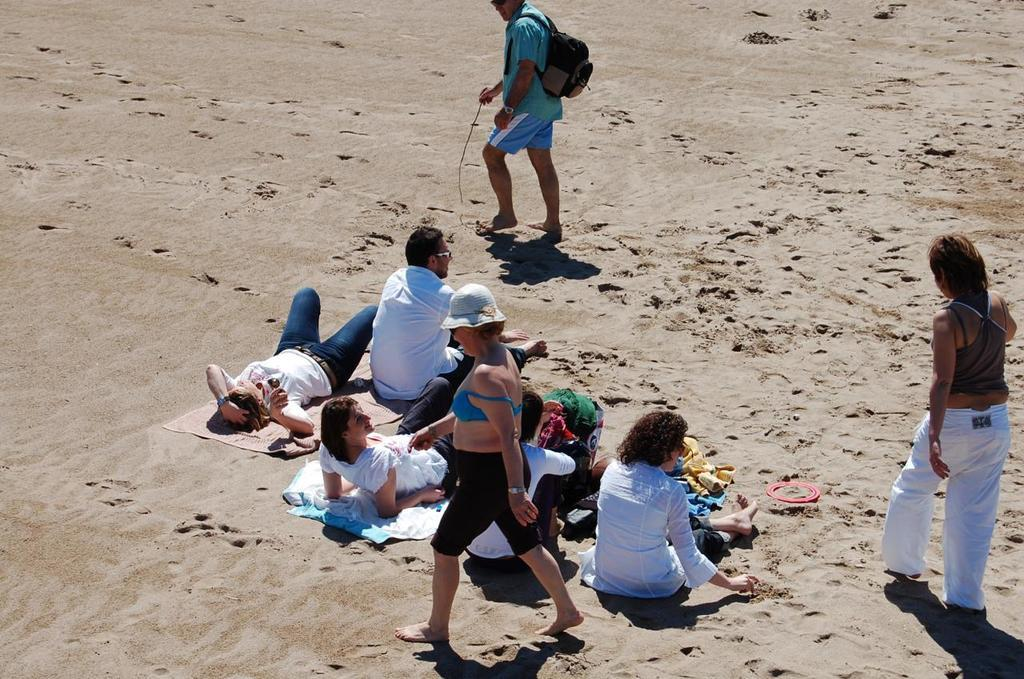What are the people in the image doing? Some people are walking, and some people are sitting in the image. Can you describe the actions of the man in the image? The man is carrying a bag in the image. What is present on the sand in the image? Clothes and objects are visible on the sand. Can you see any badges on the people in the image? There is no mention of badges in the provided facts, so we cannot determine if any are present in the image. What is the limit of the objects on the sand in the image? There is no mention of a limit for the objects on the sand in the provided facts, so we cannot determine a limit from the image. 